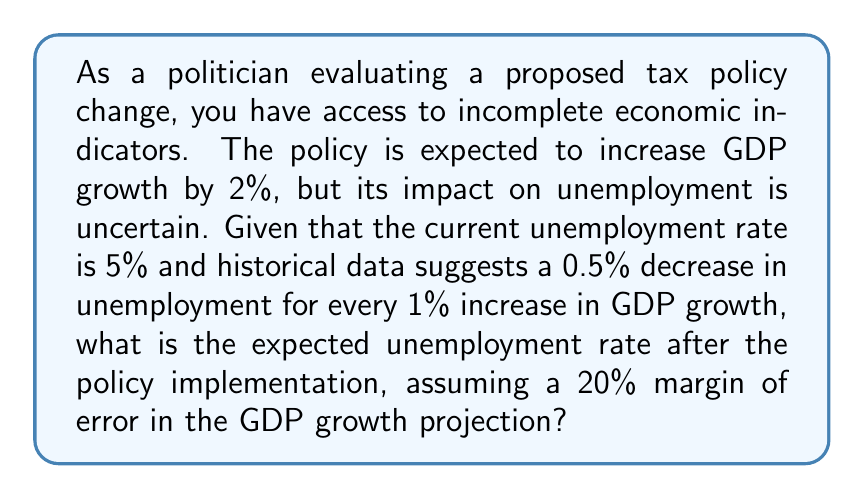Show me your answer to this math problem. To solve this problem, we'll follow these steps:

1. Calculate the expected change in unemployment based on the projected GDP growth:
   $$\text{Expected change} = -0.5\% \times 2\% = -1\%$$

2. Calculate the new expected unemployment rate:
   $$\text{New rate} = 5\% - 1\% = 4\%$$

3. Account for the 20% margin of error in GDP growth:
   $$\text{GDP growth range} = 2\% \pm (20\% \times 2\%) = [1.6\%, 2.4\%]$$

4. Calculate the range of possible unemployment changes:
   $$\text{Min change} = -0.5\% \times 1.6\% = -0.8\%$$
   $$\text{Max change} = -0.5\% \times 2.4\% = -1.2\%$$

5. Calculate the range of possible new unemployment rates:
   $$\text{Max new rate} = 5\% - 0.8\% = 4.2\%$$
   $$\text{Min new rate} = 5\% - 1.2\% = 3.8\%$$

6. Express the expected unemployment rate as a range:
   $$\text{Expected unemployment rate} = [3.8\%, 4.2\%]$$
Answer: [3.8%, 4.2%] 